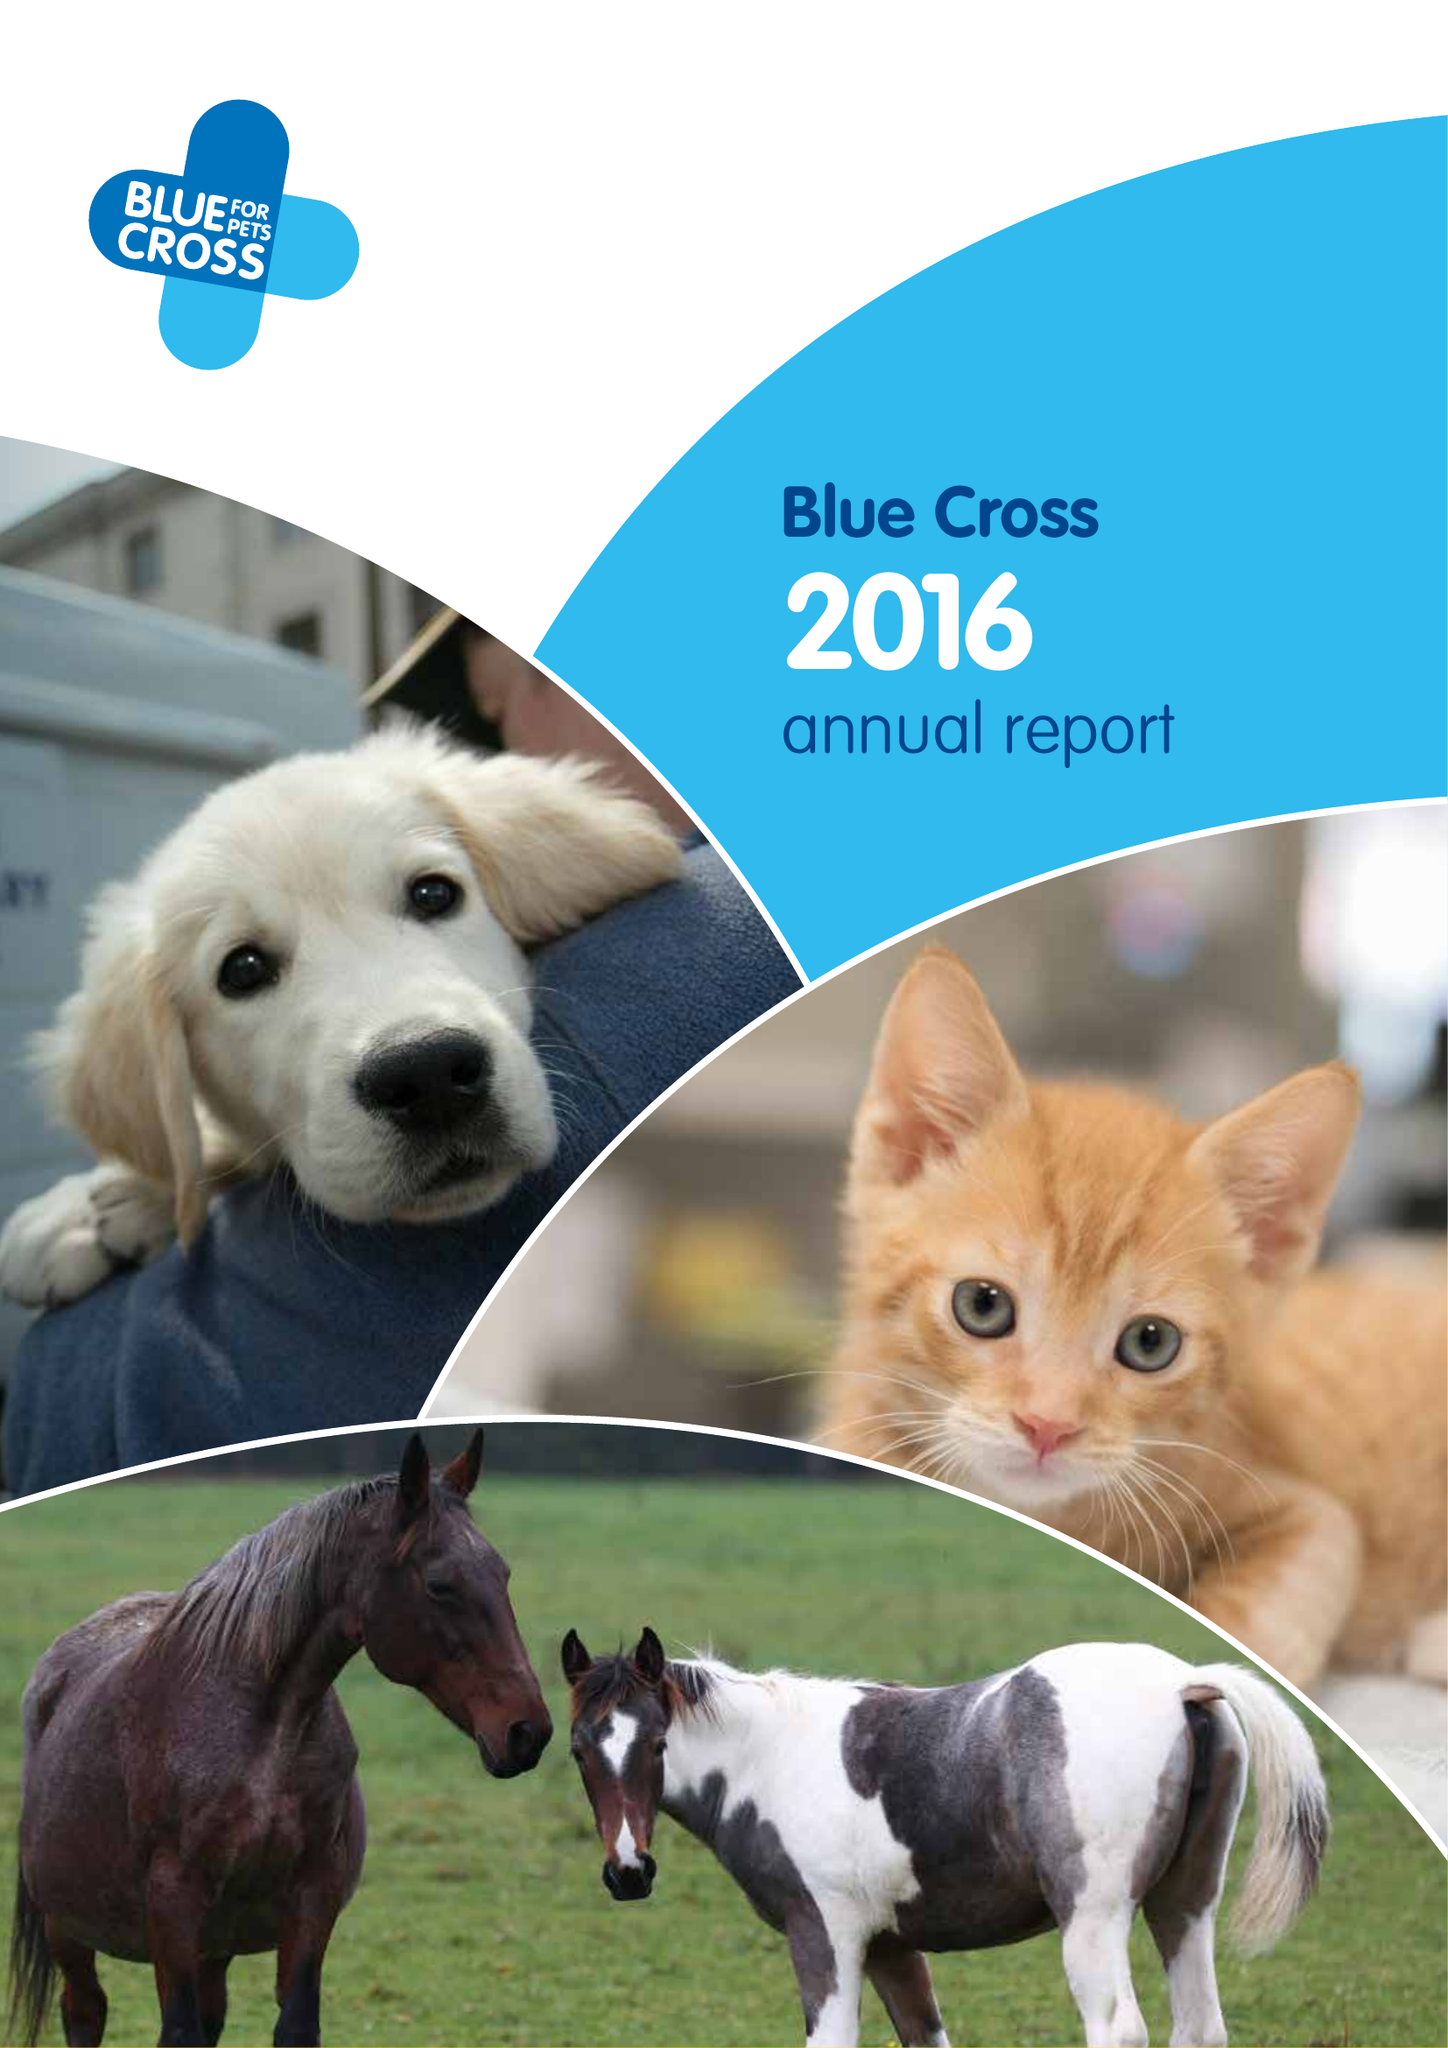What is the value for the address__postcode?
Answer the question using a single word or phrase. OX18 4PF 